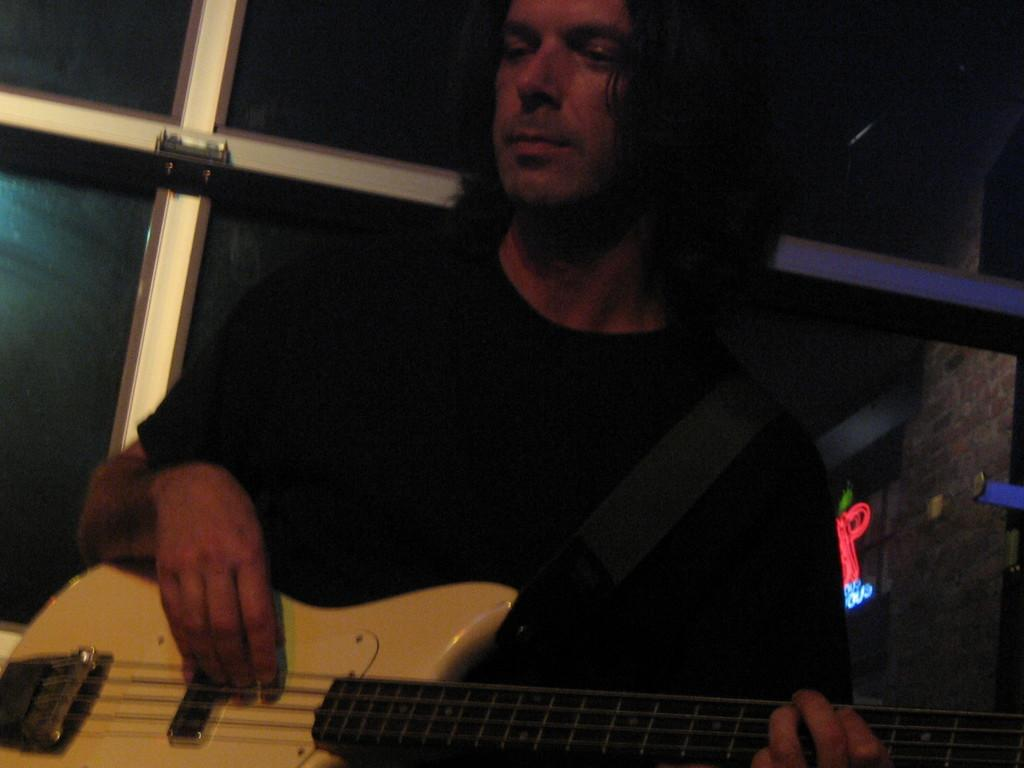What is the main subject of the image? The main subject of the image is a musician. What instrument is the musician holding? The musician is holding a guitar. What can be seen in the background of the image? There is a building in the background of the image. Are there any active volcanoes visible in the image? No, there are no volcanoes present in the image. What type of love is being expressed by the musician in the image? There is no indication of love or any emotion being expressed by the musician in the image. 